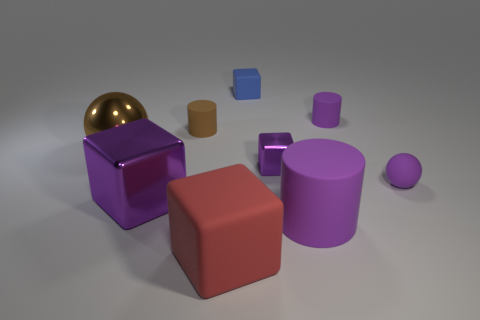There is a big cylinder that is the same color as the tiny metal object; what is its material?
Provide a short and direct response. Rubber. What number of other things are there of the same color as the large rubber cylinder?
Make the answer very short. 4. How many cylinders are tiny brown things or large brown metallic objects?
Provide a succinct answer. 1. What color is the big sphere in front of the purple object that is behind the brown cylinder?
Keep it short and to the point. Brown. The red matte thing has what shape?
Offer a very short reply. Cube. There is a matte cube in front of the blue thing; is it the same size as the small brown matte object?
Ensure brevity in your answer.  No. Is there a tiny purple block made of the same material as the big red thing?
Make the answer very short. No. What number of objects are rubber blocks that are behind the tiny purple matte cylinder or brown rubber cylinders?
Your response must be concise. 2. Are there any small purple things?
Provide a short and direct response. Yes. The object that is both in front of the brown ball and on the right side of the big purple rubber object has what shape?
Keep it short and to the point. Sphere. 